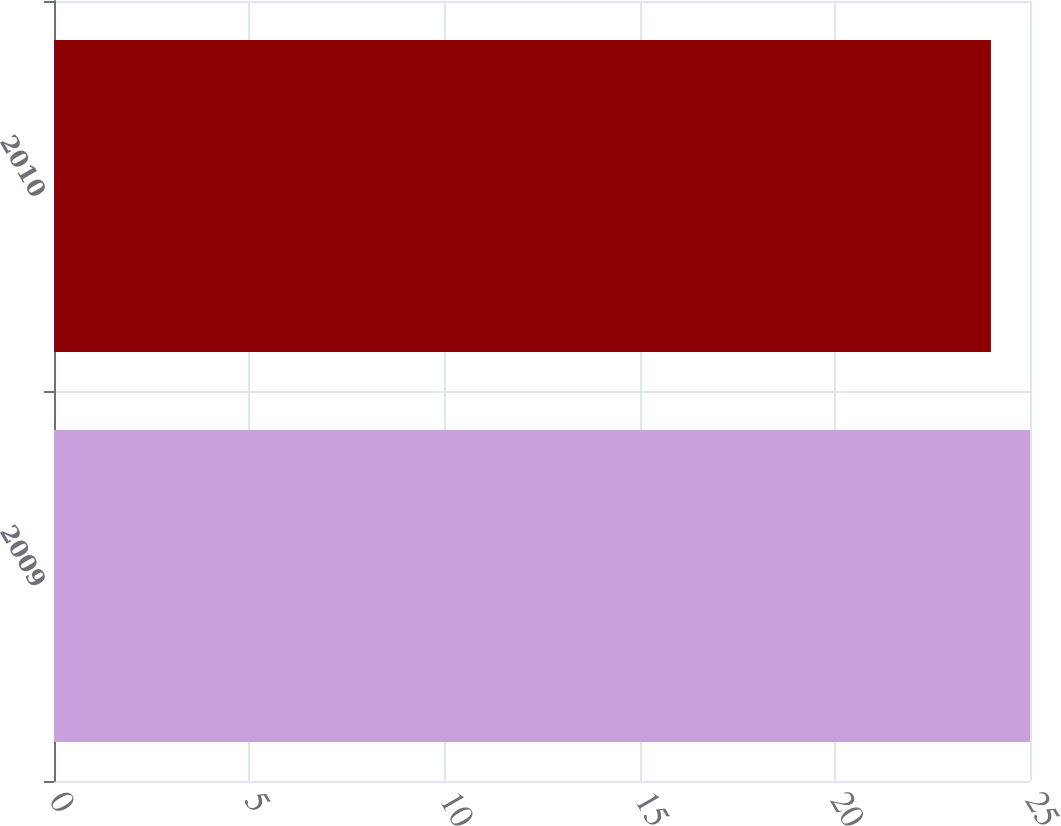Convert chart. <chart><loc_0><loc_0><loc_500><loc_500><bar_chart><fcel>2009<fcel>2010<nl><fcel>25<fcel>24<nl></chart> 